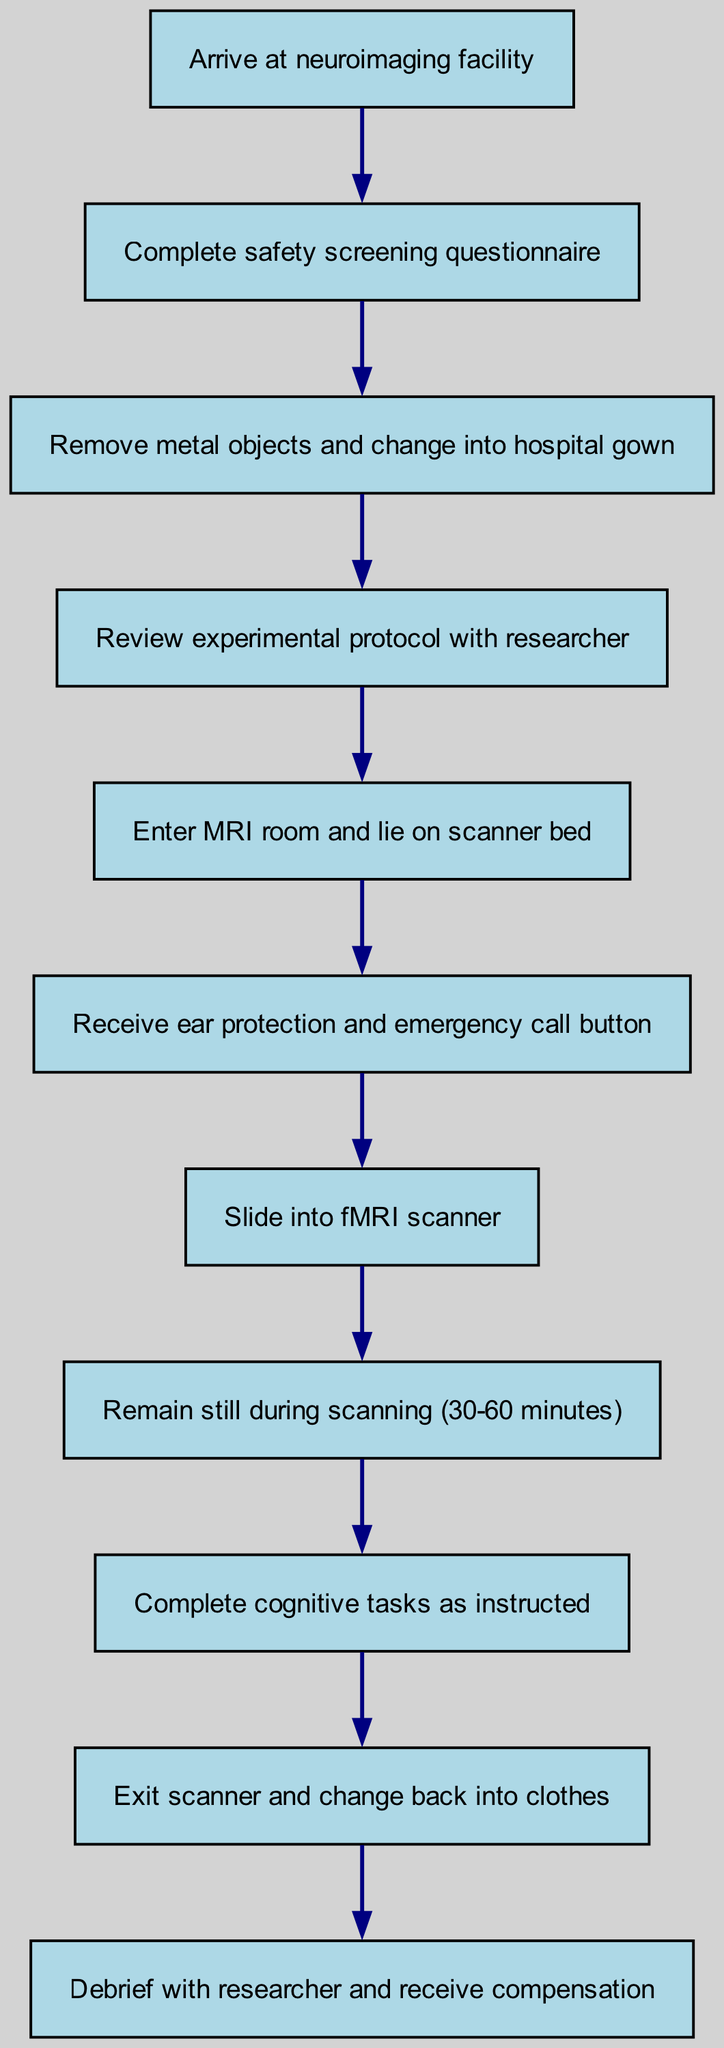What is the first step upon arrival? The first step listed in the diagram is "Arrive at neuroimaging facility" which indicates what the participant needs to do when they first arrive.
Answer: Arrive at neuroimaging facility How many total steps are there in the flowchart? By counting the nodes in the diagram, there are a total of 11 steps present from the beginning to the end of the fMRI scan process.
Answer: 11 What do you do after completing the safety screening questionnaire? According to the flowchart, after completing the safety screening questionnaire, the next step is to "Remove metal objects and change into hospital gown".
Answer: Remove metal objects and change into hospital gown Which step involves receiving ear protection? The step that involves receiving ear protection is "Receive ear protection and emergency call button", which comes after lying on the scanner bed.
Answer: Receive ear protection and emergency call button What is the last action taken after exiting the scanner? The last action listed in the flowchart after exiting the scanner is to "Debrief with researcher and receive compensation". This concludes the scanning process.
Answer: Debrief with researcher and receive compensation What step must be taken before entering the MRI room? Before entering the MRI room, the step that must be completed is "Review experimental protocol with researcher", which ensures the participant understands the study they are involved in.
Answer: Review experimental protocol with researcher During which step must the participant remain still? The participant must remain still during the step labeled "Remain still during scanning (30-60 minutes)", which is essential for obtaining quality imaging data from the fMRI scan.
Answer: Remain still during scanning (30-60 minutes) What is needed for communication during the scan? During the scan, the participant will need "ear protection and emergency call button" to communicate in case of any issues or discomfort.
Answer: Ear protection and emergency call button What is the immediate action after lying on the scanner bed? Immediately after lying on the scanner bed, the participant must "Receive ear protection and emergency call button", ensuring they are equipped for the scanning process.
Answer: Receive ear protection and emergency call button 